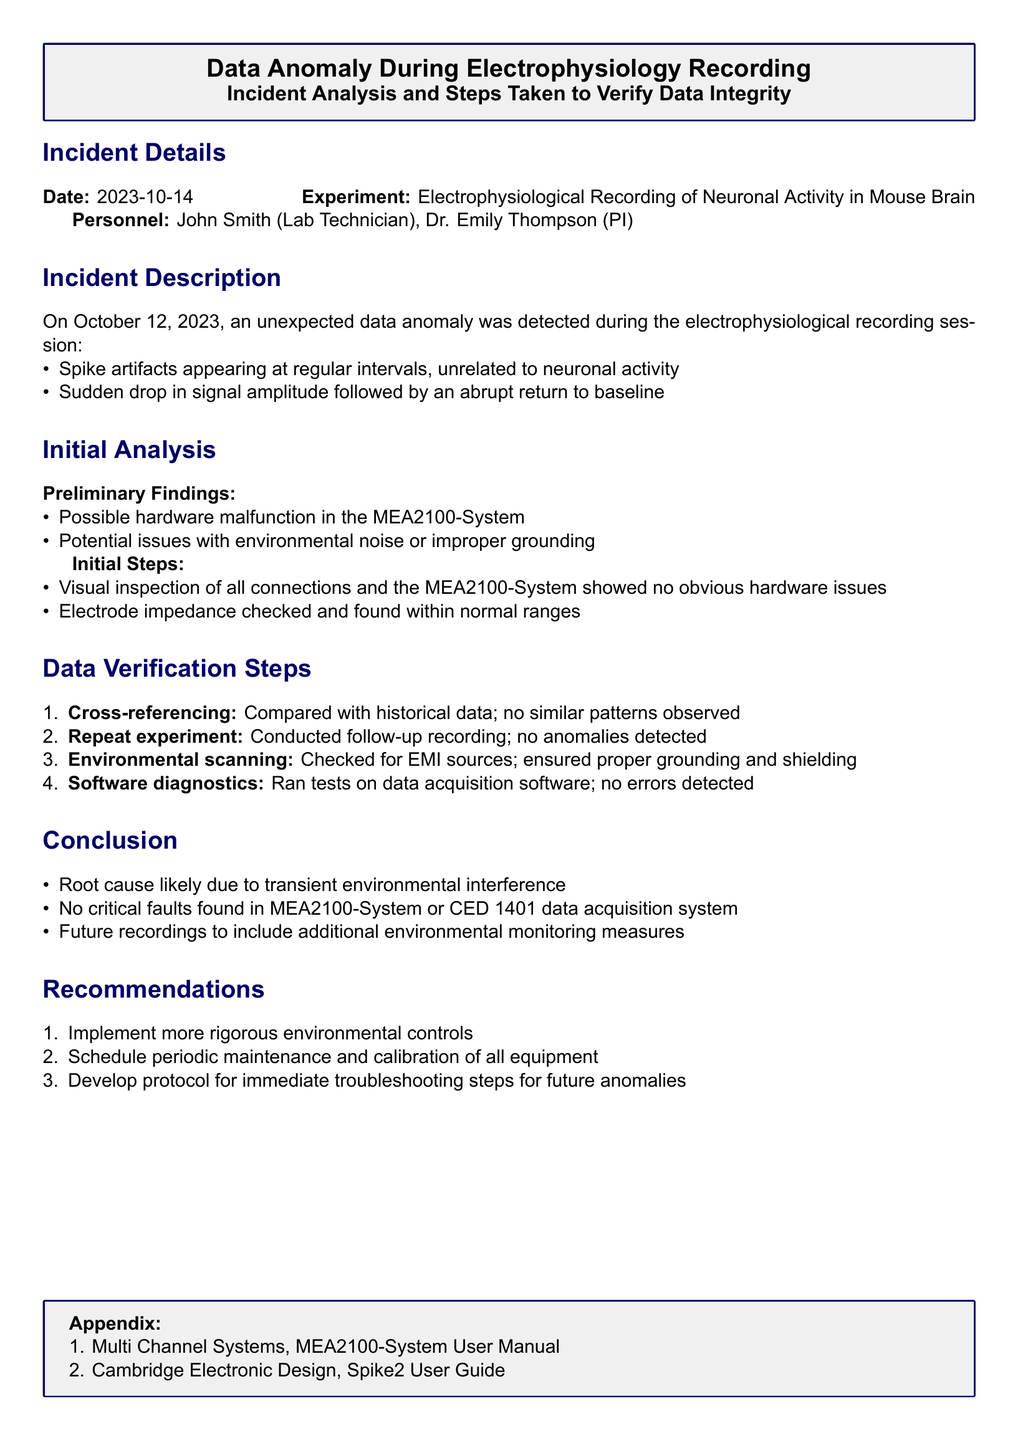What date was the incident reported? The incident report details the date as October 14, 2023.
Answer: October 14, 2023 Who conducted the electrophysiological recording? The report states that the electrophysiological recording was conducted by personnel John Smith and Dr. Emily Thompson.
Answer: John Smith and Dr. Emily Thompson What was the unexpected issue observed during the recording? An unexpected data anomaly included spike artifacts appearing at regular intervals, which were unrelated to neuronal activity.
Answer: Spike artifacts What findings suggest a cause for the anomaly? The preliminary findings indicated a possible hardware malfunction in the MEA2100-System or issues with environmental noise.
Answer: Hardware malfunction How many steps were taken for data verification? The report lists four steps taken to verify the data.
Answer: Four steps What was identified as the likely root cause of the data anomaly? The root cause of the data anomaly was likely due to transient environmental interference.
Answer: Transient environmental interference What recommendations were made for future recordings? Future recordings were recommended to include additional environmental monitoring measures.
Answer: Additional environmental monitoring measures Which system underwent visual inspection? The MEA2100-System underwent a visual inspection as part of the initial steps.
Answer: MEA2100-System 